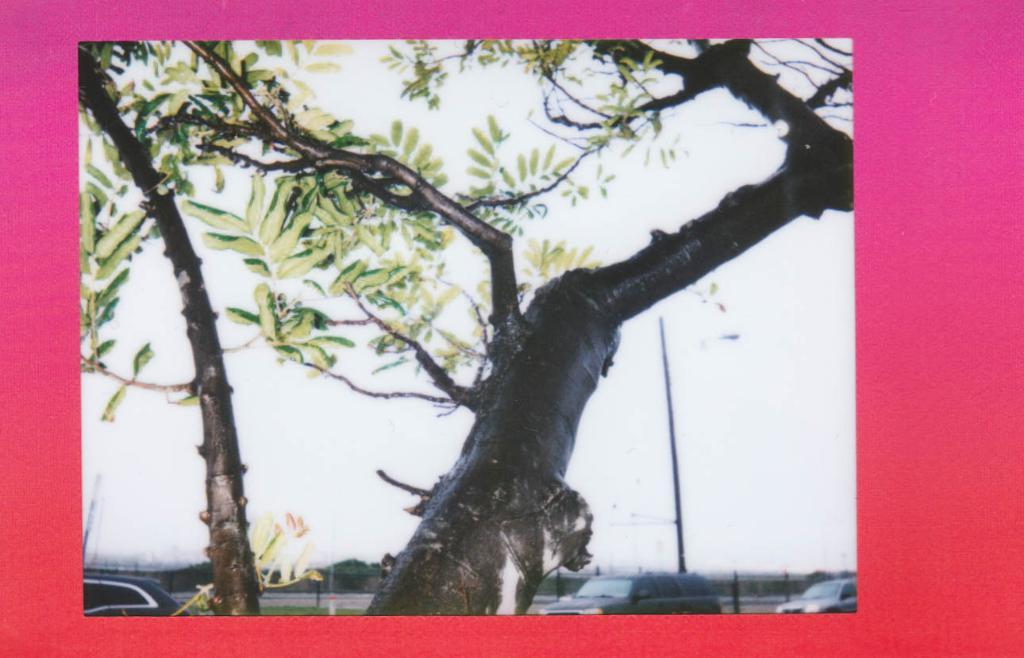What type of plant is present in the image? There is a tree with green leaves in the image. What can be seen happening on the road in the image? Cars are moving on the road in the image. What part of the natural environment is visible in the image? The sky is visible at the top of the image. What animals can be seen in the aftermath of the zoo in the image? There is no mention of a zoo or any animals in the image. The image features a tree, cars on a road, and the sky. 